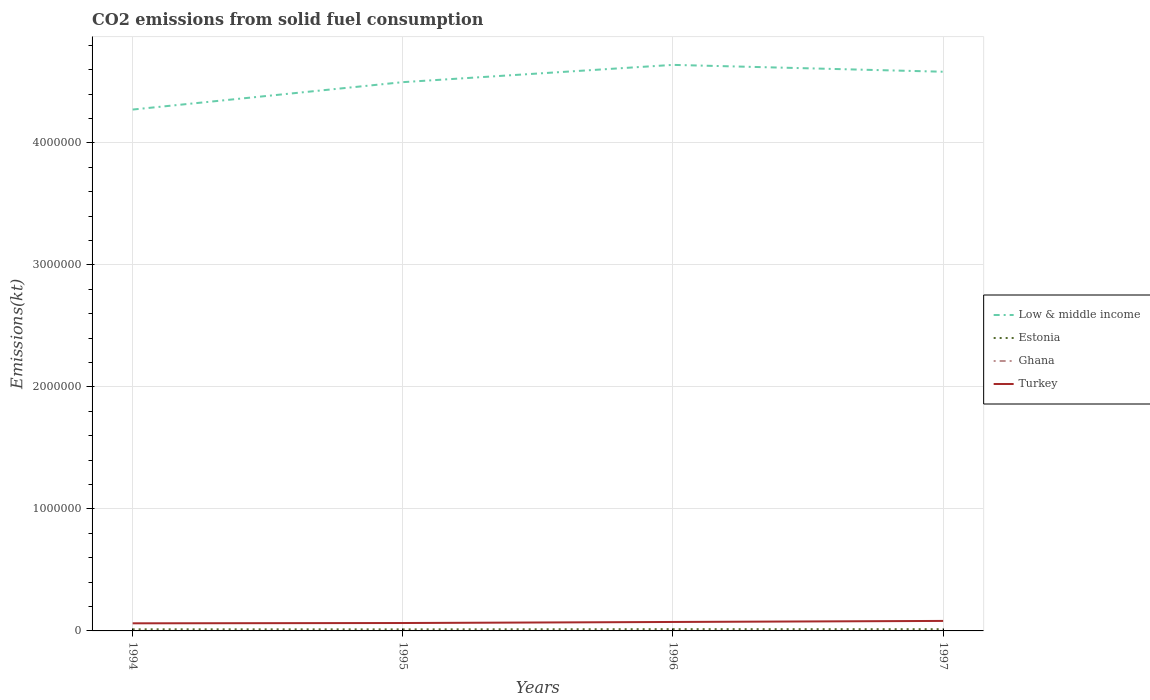How many different coloured lines are there?
Offer a terse response. 4. Across all years, what is the maximum amount of CO2 emitted in Estonia?
Make the answer very short. 1.28e+04. What is the total amount of CO2 emitted in Turkey in the graph?
Keep it short and to the point. -8507.44. What is the difference between the highest and the second highest amount of CO2 emitted in Estonia?
Provide a short and direct response. 1734.49. Are the values on the major ticks of Y-axis written in scientific E-notation?
Make the answer very short. No. Does the graph contain grids?
Your answer should be very brief. Yes. Where does the legend appear in the graph?
Ensure brevity in your answer.  Center right. How many legend labels are there?
Keep it short and to the point. 4. What is the title of the graph?
Offer a very short reply. CO2 emissions from solid fuel consumption. What is the label or title of the X-axis?
Ensure brevity in your answer.  Years. What is the label or title of the Y-axis?
Your answer should be compact. Emissions(kt). What is the Emissions(kt) in Low & middle income in 1994?
Keep it short and to the point. 4.27e+06. What is the Emissions(kt) of Estonia in 1994?
Your answer should be very brief. 1.34e+04. What is the Emissions(kt) of Ghana in 1994?
Provide a short and direct response. 7.33. What is the Emissions(kt) in Turkey in 1994?
Offer a very short reply. 6.24e+04. What is the Emissions(kt) of Low & middle income in 1995?
Provide a succinct answer. 4.50e+06. What is the Emissions(kt) in Estonia in 1995?
Your response must be concise. 1.28e+04. What is the Emissions(kt) of Ghana in 1995?
Give a very brief answer. 7.33. What is the Emissions(kt) of Turkey in 1995?
Make the answer very short. 6.48e+04. What is the Emissions(kt) of Low & middle income in 1996?
Offer a very short reply. 4.64e+06. What is the Emissions(kt) in Estonia in 1996?
Your answer should be very brief. 1.45e+04. What is the Emissions(kt) in Ghana in 1996?
Offer a very short reply. 7.33. What is the Emissions(kt) in Turkey in 1996?
Give a very brief answer. 7.34e+04. What is the Emissions(kt) in Low & middle income in 1997?
Your response must be concise. 4.58e+06. What is the Emissions(kt) of Estonia in 1997?
Give a very brief answer. 1.42e+04. What is the Emissions(kt) of Ghana in 1997?
Provide a short and direct response. 7.33. What is the Emissions(kt) of Turkey in 1997?
Offer a very short reply. 8.19e+04. Across all years, what is the maximum Emissions(kt) of Low & middle income?
Ensure brevity in your answer.  4.64e+06. Across all years, what is the maximum Emissions(kt) of Estonia?
Your answer should be compact. 1.45e+04. Across all years, what is the maximum Emissions(kt) in Ghana?
Ensure brevity in your answer.  7.33. Across all years, what is the maximum Emissions(kt) in Turkey?
Ensure brevity in your answer.  8.19e+04. Across all years, what is the minimum Emissions(kt) in Low & middle income?
Your answer should be very brief. 4.27e+06. Across all years, what is the minimum Emissions(kt) in Estonia?
Provide a succinct answer. 1.28e+04. Across all years, what is the minimum Emissions(kt) of Ghana?
Keep it short and to the point. 7.33. Across all years, what is the minimum Emissions(kt) of Turkey?
Give a very brief answer. 6.24e+04. What is the total Emissions(kt) in Low & middle income in the graph?
Your response must be concise. 1.80e+07. What is the total Emissions(kt) in Estonia in the graph?
Give a very brief answer. 5.48e+04. What is the total Emissions(kt) in Ghana in the graph?
Provide a succinct answer. 29.34. What is the total Emissions(kt) in Turkey in the graph?
Offer a terse response. 2.83e+05. What is the difference between the Emissions(kt) of Low & middle income in 1994 and that in 1995?
Provide a succinct answer. -2.25e+05. What is the difference between the Emissions(kt) in Estonia in 1994 and that in 1995?
Your response must be concise. 608.72. What is the difference between the Emissions(kt) in Ghana in 1994 and that in 1995?
Make the answer very short. 0. What is the difference between the Emissions(kt) in Turkey in 1994 and that in 1995?
Offer a very short reply. -2365.22. What is the difference between the Emissions(kt) in Low & middle income in 1994 and that in 1996?
Keep it short and to the point. -3.66e+05. What is the difference between the Emissions(kt) in Estonia in 1994 and that in 1996?
Keep it short and to the point. -1125.77. What is the difference between the Emissions(kt) in Ghana in 1994 and that in 1996?
Ensure brevity in your answer.  0. What is the difference between the Emissions(kt) of Turkey in 1994 and that in 1996?
Keep it short and to the point. -1.10e+04. What is the difference between the Emissions(kt) in Low & middle income in 1994 and that in 1997?
Ensure brevity in your answer.  -3.10e+05. What is the difference between the Emissions(kt) of Estonia in 1994 and that in 1997?
Provide a succinct answer. -792.07. What is the difference between the Emissions(kt) of Turkey in 1994 and that in 1997?
Keep it short and to the point. -1.96e+04. What is the difference between the Emissions(kt) of Low & middle income in 1995 and that in 1996?
Your answer should be compact. -1.42e+05. What is the difference between the Emissions(kt) in Estonia in 1995 and that in 1996?
Your answer should be very brief. -1734.49. What is the difference between the Emissions(kt) of Ghana in 1995 and that in 1996?
Provide a succinct answer. 0. What is the difference between the Emissions(kt) in Turkey in 1995 and that in 1996?
Keep it short and to the point. -8679.79. What is the difference between the Emissions(kt) of Low & middle income in 1995 and that in 1997?
Provide a short and direct response. -8.53e+04. What is the difference between the Emissions(kt) of Estonia in 1995 and that in 1997?
Your response must be concise. -1400.79. What is the difference between the Emissions(kt) in Ghana in 1995 and that in 1997?
Your response must be concise. 0. What is the difference between the Emissions(kt) of Turkey in 1995 and that in 1997?
Ensure brevity in your answer.  -1.72e+04. What is the difference between the Emissions(kt) of Low & middle income in 1996 and that in 1997?
Give a very brief answer. 5.63e+04. What is the difference between the Emissions(kt) in Estonia in 1996 and that in 1997?
Ensure brevity in your answer.  333.7. What is the difference between the Emissions(kt) in Turkey in 1996 and that in 1997?
Keep it short and to the point. -8507.44. What is the difference between the Emissions(kt) in Low & middle income in 1994 and the Emissions(kt) in Estonia in 1995?
Keep it short and to the point. 4.26e+06. What is the difference between the Emissions(kt) of Low & middle income in 1994 and the Emissions(kt) of Ghana in 1995?
Give a very brief answer. 4.27e+06. What is the difference between the Emissions(kt) in Low & middle income in 1994 and the Emissions(kt) in Turkey in 1995?
Offer a very short reply. 4.21e+06. What is the difference between the Emissions(kt) in Estonia in 1994 and the Emissions(kt) in Ghana in 1995?
Provide a short and direct response. 1.34e+04. What is the difference between the Emissions(kt) of Estonia in 1994 and the Emissions(kt) of Turkey in 1995?
Ensure brevity in your answer.  -5.14e+04. What is the difference between the Emissions(kt) in Ghana in 1994 and the Emissions(kt) in Turkey in 1995?
Offer a very short reply. -6.47e+04. What is the difference between the Emissions(kt) in Low & middle income in 1994 and the Emissions(kt) in Estonia in 1996?
Provide a succinct answer. 4.26e+06. What is the difference between the Emissions(kt) of Low & middle income in 1994 and the Emissions(kt) of Ghana in 1996?
Offer a terse response. 4.27e+06. What is the difference between the Emissions(kt) of Low & middle income in 1994 and the Emissions(kt) of Turkey in 1996?
Offer a terse response. 4.20e+06. What is the difference between the Emissions(kt) in Estonia in 1994 and the Emissions(kt) in Ghana in 1996?
Offer a terse response. 1.34e+04. What is the difference between the Emissions(kt) of Estonia in 1994 and the Emissions(kt) of Turkey in 1996?
Offer a terse response. -6.01e+04. What is the difference between the Emissions(kt) of Ghana in 1994 and the Emissions(kt) of Turkey in 1996?
Provide a succinct answer. -7.34e+04. What is the difference between the Emissions(kt) of Low & middle income in 1994 and the Emissions(kt) of Estonia in 1997?
Ensure brevity in your answer.  4.26e+06. What is the difference between the Emissions(kt) in Low & middle income in 1994 and the Emissions(kt) in Ghana in 1997?
Your answer should be compact. 4.27e+06. What is the difference between the Emissions(kt) of Low & middle income in 1994 and the Emissions(kt) of Turkey in 1997?
Give a very brief answer. 4.19e+06. What is the difference between the Emissions(kt) of Estonia in 1994 and the Emissions(kt) of Ghana in 1997?
Offer a very short reply. 1.34e+04. What is the difference between the Emissions(kt) in Estonia in 1994 and the Emissions(kt) in Turkey in 1997?
Provide a succinct answer. -6.86e+04. What is the difference between the Emissions(kt) in Ghana in 1994 and the Emissions(kt) in Turkey in 1997?
Offer a terse response. -8.19e+04. What is the difference between the Emissions(kt) of Low & middle income in 1995 and the Emissions(kt) of Estonia in 1996?
Ensure brevity in your answer.  4.48e+06. What is the difference between the Emissions(kt) in Low & middle income in 1995 and the Emissions(kt) in Ghana in 1996?
Make the answer very short. 4.50e+06. What is the difference between the Emissions(kt) in Low & middle income in 1995 and the Emissions(kt) in Turkey in 1996?
Give a very brief answer. 4.42e+06. What is the difference between the Emissions(kt) of Estonia in 1995 and the Emissions(kt) of Ghana in 1996?
Offer a terse response. 1.28e+04. What is the difference between the Emissions(kt) in Estonia in 1995 and the Emissions(kt) in Turkey in 1996?
Give a very brief answer. -6.07e+04. What is the difference between the Emissions(kt) in Ghana in 1995 and the Emissions(kt) in Turkey in 1996?
Your response must be concise. -7.34e+04. What is the difference between the Emissions(kt) of Low & middle income in 1995 and the Emissions(kt) of Estonia in 1997?
Offer a terse response. 4.48e+06. What is the difference between the Emissions(kt) of Low & middle income in 1995 and the Emissions(kt) of Ghana in 1997?
Your answer should be compact. 4.50e+06. What is the difference between the Emissions(kt) of Low & middle income in 1995 and the Emissions(kt) of Turkey in 1997?
Ensure brevity in your answer.  4.42e+06. What is the difference between the Emissions(kt) of Estonia in 1995 and the Emissions(kt) of Ghana in 1997?
Your response must be concise. 1.28e+04. What is the difference between the Emissions(kt) of Estonia in 1995 and the Emissions(kt) of Turkey in 1997?
Your answer should be very brief. -6.92e+04. What is the difference between the Emissions(kt) of Ghana in 1995 and the Emissions(kt) of Turkey in 1997?
Offer a very short reply. -8.19e+04. What is the difference between the Emissions(kt) in Low & middle income in 1996 and the Emissions(kt) in Estonia in 1997?
Your answer should be very brief. 4.63e+06. What is the difference between the Emissions(kt) in Low & middle income in 1996 and the Emissions(kt) in Ghana in 1997?
Keep it short and to the point. 4.64e+06. What is the difference between the Emissions(kt) in Low & middle income in 1996 and the Emissions(kt) in Turkey in 1997?
Ensure brevity in your answer.  4.56e+06. What is the difference between the Emissions(kt) of Estonia in 1996 and the Emissions(kt) of Ghana in 1997?
Your answer should be very brief. 1.45e+04. What is the difference between the Emissions(kt) of Estonia in 1996 and the Emissions(kt) of Turkey in 1997?
Offer a very short reply. -6.74e+04. What is the difference between the Emissions(kt) of Ghana in 1996 and the Emissions(kt) of Turkey in 1997?
Provide a short and direct response. -8.19e+04. What is the average Emissions(kt) of Low & middle income per year?
Your answer should be compact. 4.50e+06. What is the average Emissions(kt) in Estonia per year?
Your answer should be compact. 1.37e+04. What is the average Emissions(kt) of Ghana per year?
Keep it short and to the point. 7.33. What is the average Emissions(kt) of Turkey per year?
Offer a terse response. 7.06e+04. In the year 1994, what is the difference between the Emissions(kt) in Low & middle income and Emissions(kt) in Estonia?
Your response must be concise. 4.26e+06. In the year 1994, what is the difference between the Emissions(kt) of Low & middle income and Emissions(kt) of Ghana?
Provide a succinct answer. 4.27e+06. In the year 1994, what is the difference between the Emissions(kt) in Low & middle income and Emissions(kt) in Turkey?
Your answer should be very brief. 4.21e+06. In the year 1994, what is the difference between the Emissions(kt) of Estonia and Emissions(kt) of Ghana?
Your answer should be compact. 1.34e+04. In the year 1994, what is the difference between the Emissions(kt) of Estonia and Emissions(kt) of Turkey?
Offer a very short reply. -4.90e+04. In the year 1994, what is the difference between the Emissions(kt) in Ghana and Emissions(kt) in Turkey?
Offer a very short reply. -6.24e+04. In the year 1995, what is the difference between the Emissions(kt) in Low & middle income and Emissions(kt) in Estonia?
Offer a very short reply. 4.48e+06. In the year 1995, what is the difference between the Emissions(kt) in Low & middle income and Emissions(kt) in Ghana?
Ensure brevity in your answer.  4.50e+06. In the year 1995, what is the difference between the Emissions(kt) of Low & middle income and Emissions(kt) of Turkey?
Provide a succinct answer. 4.43e+06. In the year 1995, what is the difference between the Emissions(kt) in Estonia and Emissions(kt) in Ghana?
Your response must be concise. 1.28e+04. In the year 1995, what is the difference between the Emissions(kt) in Estonia and Emissions(kt) in Turkey?
Keep it short and to the point. -5.20e+04. In the year 1995, what is the difference between the Emissions(kt) of Ghana and Emissions(kt) of Turkey?
Offer a terse response. -6.47e+04. In the year 1996, what is the difference between the Emissions(kt) of Low & middle income and Emissions(kt) of Estonia?
Your answer should be very brief. 4.62e+06. In the year 1996, what is the difference between the Emissions(kt) of Low & middle income and Emissions(kt) of Ghana?
Ensure brevity in your answer.  4.64e+06. In the year 1996, what is the difference between the Emissions(kt) in Low & middle income and Emissions(kt) in Turkey?
Make the answer very short. 4.57e+06. In the year 1996, what is the difference between the Emissions(kt) in Estonia and Emissions(kt) in Ghana?
Ensure brevity in your answer.  1.45e+04. In the year 1996, what is the difference between the Emissions(kt) of Estonia and Emissions(kt) of Turkey?
Keep it short and to the point. -5.89e+04. In the year 1996, what is the difference between the Emissions(kt) in Ghana and Emissions(kt) in Turkey?
Offer a very short reply. -7.34e+04. In the year 1997, what is the difference between the Emissions(kt) of Low & middle income and Emissions(kt) of Estonia?
Keep it short and to the point. 4.57e+06. In the year 1997, what is the difference between the Emissions(kt) in Low & middle income and Emissions(kt) in Ghana?
Keep it short and to the point. 4.58e+06. In the year 1997, what is the difference between the Emissions(kt) of Low & middle income and Emissions(kt) of Turkey?
Offer a very short reply. 4.50e+06. In the year 1997, what is the difference between the Emissions(kt) of Estonia and Emissions(kt) of Ghana?
Offer a very short reply. 1.42e+04. In the year 1997, what is the difference between the Emissions(kt) in Estonia and Emissions(kt) in Turkey?
Give a very brief answer. -6.78e+04. In the year 1997, what is the difference between the Emissions(kt) in Ghana and Emissions(kt) in Turkey?
Make the answer very short. -8.19e+04. What is the ratio of the Emissions(kt) in Low & middle income in 1994 to that in 1995?
Keep it short and to the point. 0.95. What is the ratio of the Emissions(kt) of Estonia in 1994 to that in 1995?
Provide a short and direct response. 1.05. What is the ratio of the Emissions(kt) of Ghana in 1994 to that in 1995?
Provide a succinct answer. 1. What is the ratio of the Emissions(kt) in Turkey in 1994 to that in 1995?
Provide a short and direct response. 0.96. What is the ratio of the Emissions(kt) of Low & middle income in 1994 to that in 1996?
Your response must be concise. 0.92. What is the ratio of the Emissions(kt) in Estonia in 1994 to that in 1996?
Your answer should be compact. 0.92. What is the ratio of the Emissions(kt) in Turkey in 1994 to that in 1996?
Ensure brevity in your answer.  0.85. What is the ratio of the Emissions(kt) in Low & middle income in 1994 to that in 1997?
Offer a very short reply. 0.93. What is the ratio of the Emissions(kt) of Estonia in 1994 to that in 1997?
Your answer should be compact. 0.94. What is the ratio of the Emissions(kt) in Turkey in 1994 to that in 1997?
Provide a succinct answer. 0.76. What is the ratio of the Emissions(kt) in Low & middle income in 1995 to that in 1996?
Offer a terse response. 0.97. What is the ratio of the Emissions(kt) of Estonia in 1995 to that in 1996?
Keep it short and to the point. 0.88. What is the ratio of the Emissions(kt) in Turkey in 1995 to that in 1996?
Give a very brief answer. 0.88. What is the ratio of the Emissions(kt) in Low & middle income in 1995 to that in 1997?
Make the answer very short. 0.98. What is the ratio of the Emissions(kt) of Estonia in 1995 to that in 1997?
Your response must be concise. 0.9. What is the ratio of the Emissions(kt) of Ghana in 1995 to that in 1997?
Offer a very short reply. 1. What is the ratio of the Emissions(kt) of Turkey in 1995 to that in 1997?
Your response must be concise. 0.79. What is the ratio of the Emissions(kt) in Low & middle income in 1996 to that in 1997?
Your answer should be very brief. 1.01. What is the ratio of the Emissions(kt) of Estonia in 1996 to that in 1997?
Your response must be concise. 1.02. What is the ratio of the Emissions(kt) in Turkey in 1996 to that in 1997?
Provide a short and direct response. 0.9. What is the difference between the highest and the second highest Emissions(kt) in Low & middle income?
Offer a very short reply. 5.63e+04. What is the difference between the highest and the second highest Emissions(kt) in Estonia?
Offer a very short reply. 333.7. What is the difference between the highest and the second highest Emissions(kt) of Turkey?
Ensure brevity in your answer.  8507.44. What is the difference between the highest and the lowest Emissions(kt) in Low & middle income?
Offer a very short reply. 3.66e+05. What is the difference between the highest and the lowest Emissions(kt) of Estonia?
Make the answer very short. 1734.49. What is the difference between the highest and the lowest Emissions(kt) in Ghana?
Your response must be concise. 0. What is the difference between the highest and the lowest Emissions(kt) of Turkey?
Your answer should be compact. 1.96e+04. 